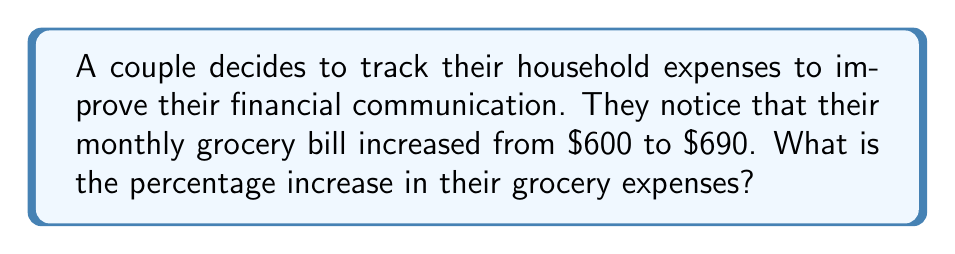Can you solve this math problem? To calculate the percentage increase, we'll follow these steps:

1. Calculate the difference between the new and old values:
   $690 - $600 = $90

2. Divide the difference by the original value:
   $\frac{90}{600} = 0.15$

3. Convert the decimal to a percentage by multiplying by 100:
   $0.15 \times 100 = 15\%$

Therefore, the percentage increase in their grocery expenses is 15%.

Alternatively, we can use the percentage increase formula:

$$\text{Percentage Increase} = \frac{\text{Increase}}{\text{Original Value}} \times 100\%$$

$$\text{Percentage Increase} = \frac{690 - 600}{600} \times 100\% = \frac{90}{600} \times 100\% = 0.15 \times 100\% = 15\%$$
Answer: 15% 